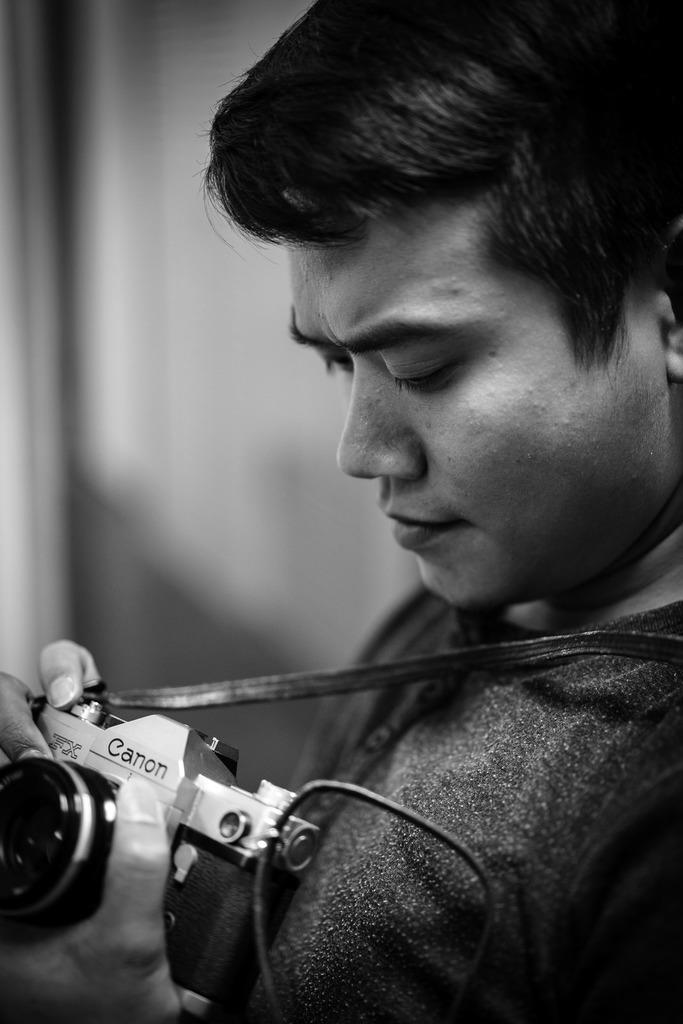What is the main subject of the image? The main subject of the image is a man. What is the man holding in his hand? The man is holding a camera in his hand. What type of act does the man perform in the image? There is no specific act being performed by the man in the image; he is simply holding a camera in his hand. What is the self-awareness level of the man in the image? The image does not provide any information about the man's self-awareness level. 